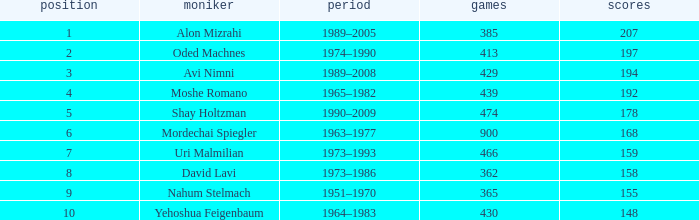What is the Rank of the player with 362 Matches? 8.0. 